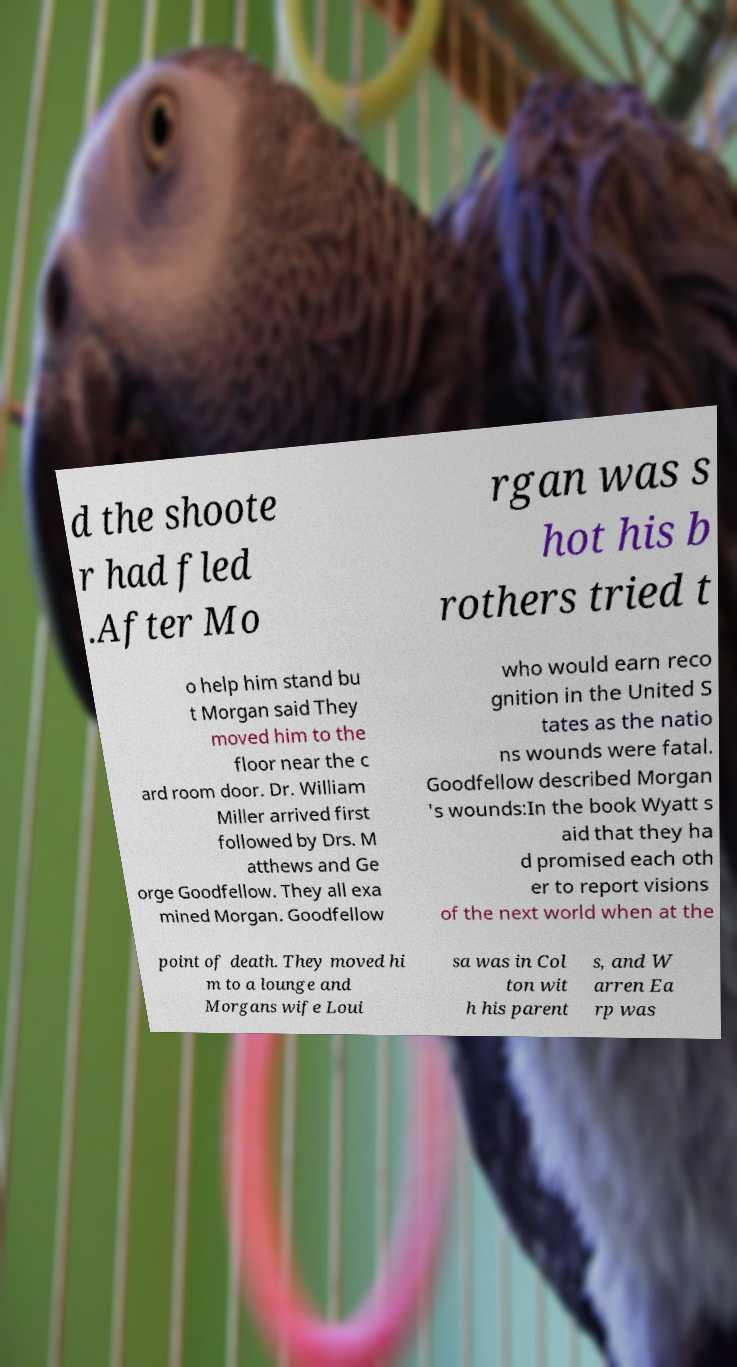Can you read and provide the text displayed in the image?This photo seems to have some interesting text. Can you extract and type it out for me? d the shoote r had fled .After Mo rgan was s hot his b rothers tried t o help him stand bu t Morgan said They moved him to the floor near the c ard room door. Dr. William Miller arrived first followed by Drs. M atthews and Ge orge Goodfellow. They all exa mined Morgan. Goodfellow who would earn reco gnition in the United S tates as the natio ns wounds were fatal. Goodfellow described Morgan 's wounds:In the book Wyatt s aid that they ha d promised each oth er to report visions of the next world when at the point of death. They moved hi m to a lounge and Morgans wife Loui sa was in Col ton wit h his parent s, and W arren Ea rp was 